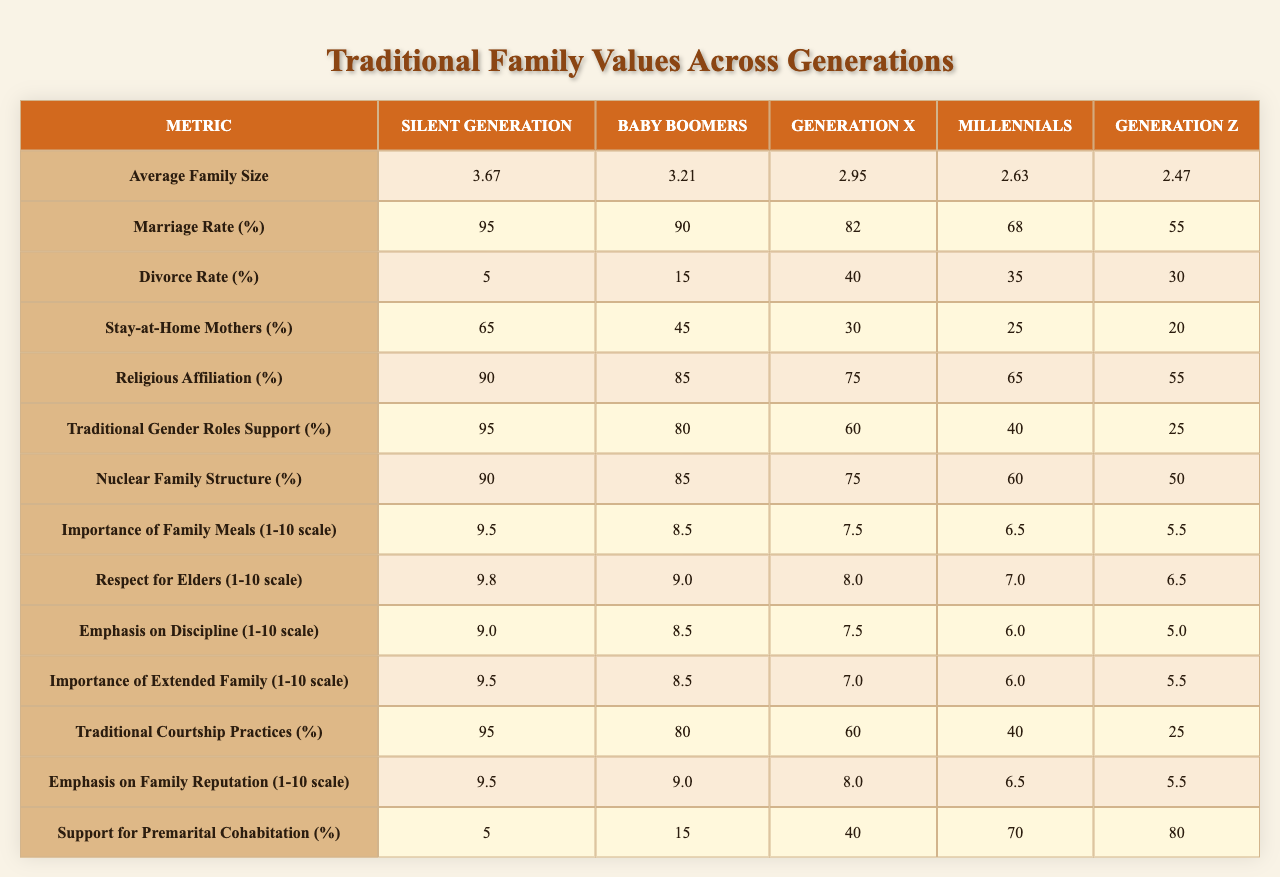What is the average family size for Millennials? According to the table, the value for Millennials under the "Average Family Size" column is 2.63.
Answer: 2.63 What percentage of the Silent Generation supports traditional gender roles? The table shows that 95% of the Silent Generation supports traditional gender roles, as indicated in the corresponding column.
Answer: 95% Which generation has the highest importance rating for family meals? The Silent Generation assigns a rating of 9.5 for the importance of family meals, which is the highest compared to other generations.
Answer: 9.5 What is the decline in the marriage rate from the Silent Generation to Generation Z? The marriage rate for the Silent Generation is 95%, and for Generation Z, it is 55%. The decline is 95% - 55% = 40%.
Answer: 40% How does the support for premarital cohabitation change from Generation X to Generation Z? Generation X supports premarital cohabitation at 40%, while Generation Z supports it at 80%. The change is 80% - 40% = 40%.
Answer: 40% Is the divorce rate higher for Millennials or Generation Z? The divorce rate for Millennials is 35%, while for Generation Z, it is 30%. Since 35% is higher than 30%, the answer is true.
Answer: True What is the average importance rating of family meals across all generations? To find the average, we sum the ratings: (9.5 + 8.5 + 7.5 + 6.5 + 5.5) = 37.5. There are 5 generations, thus the average is 37.5 / 5 = 7.5.
Answer: 7.5 Do Baby Boomers have a higher percentage of stay-at-home mothers than Generation X? Baby Boomers have 45% of stay-at-home mothers, while Generation X has 30%. Since 45% is greater than 30%, the answer is true.
Answer: True What is the difference in the nuclear family structure percentage between the Silent Generation and Millennials? The Silent Generation has 90% and Millennials have 60%. The difference is 90% - 60% = 30%.
Answer: 30% Which generation has the lowest support for traditional courtship practices? The table indicates that Generation Z has 25% support for traditional courtship practices, which is the lowest among all generations.
Answer: 25% 